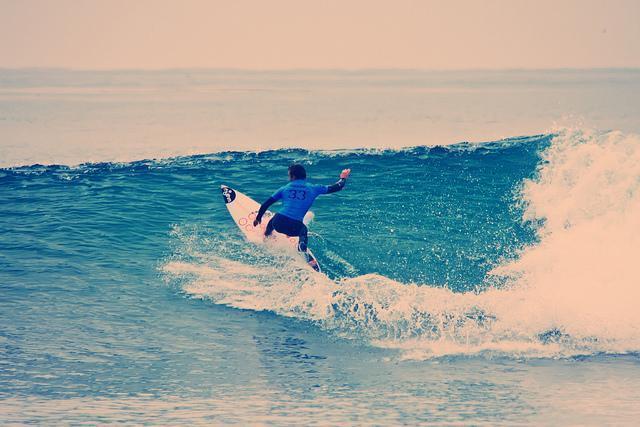How many people are in the water?
Give a very brief answer. 1. 